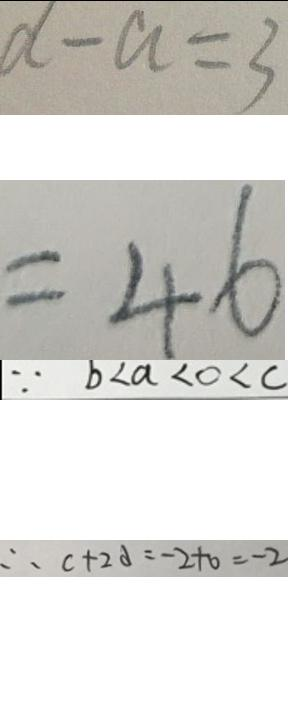<formula> <loc_0><loc_0><loc_500><loc_500>d - a = 3 
 = 4 6 
 \because b < a < 0 < c 
 \therefore c + 2 d = - 2 + 0 = - 2</formula> 